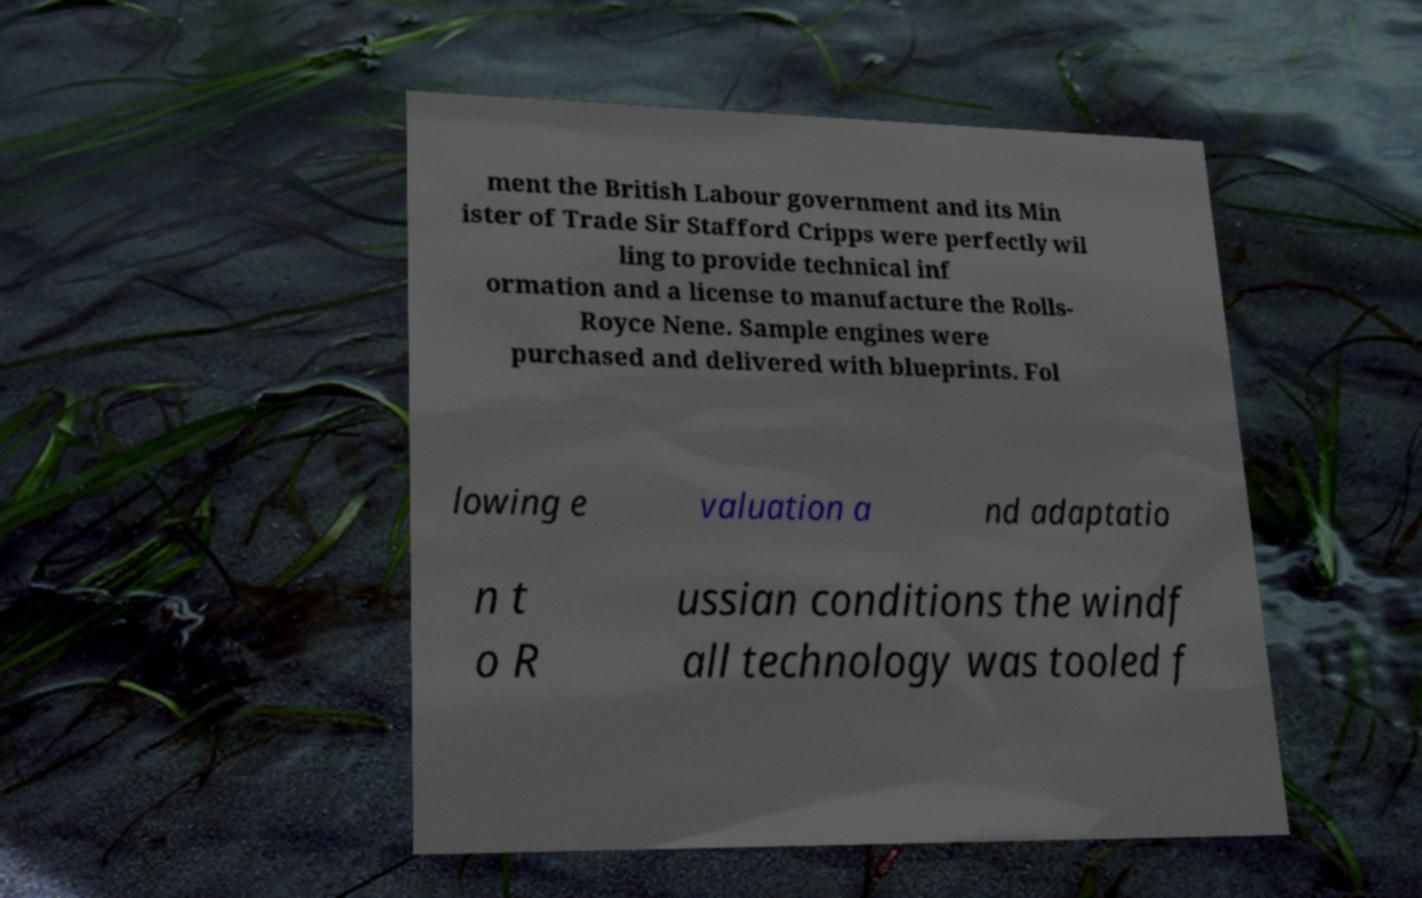There's text embedded in this image that I need extracted. Can you transcribe it verbatim? ment the British Labour government and its Min ister of Trade Sir Stafford Cripps were perfectly wil ling to provide technical inf ormation and a license to manufacture the Rolls- Royce Nene. Sample engines were purchased and delivered with blueprints. Fol lowing e valuation a nd adaptatio n t o R ussian conditions the windf all technology was tooled f 